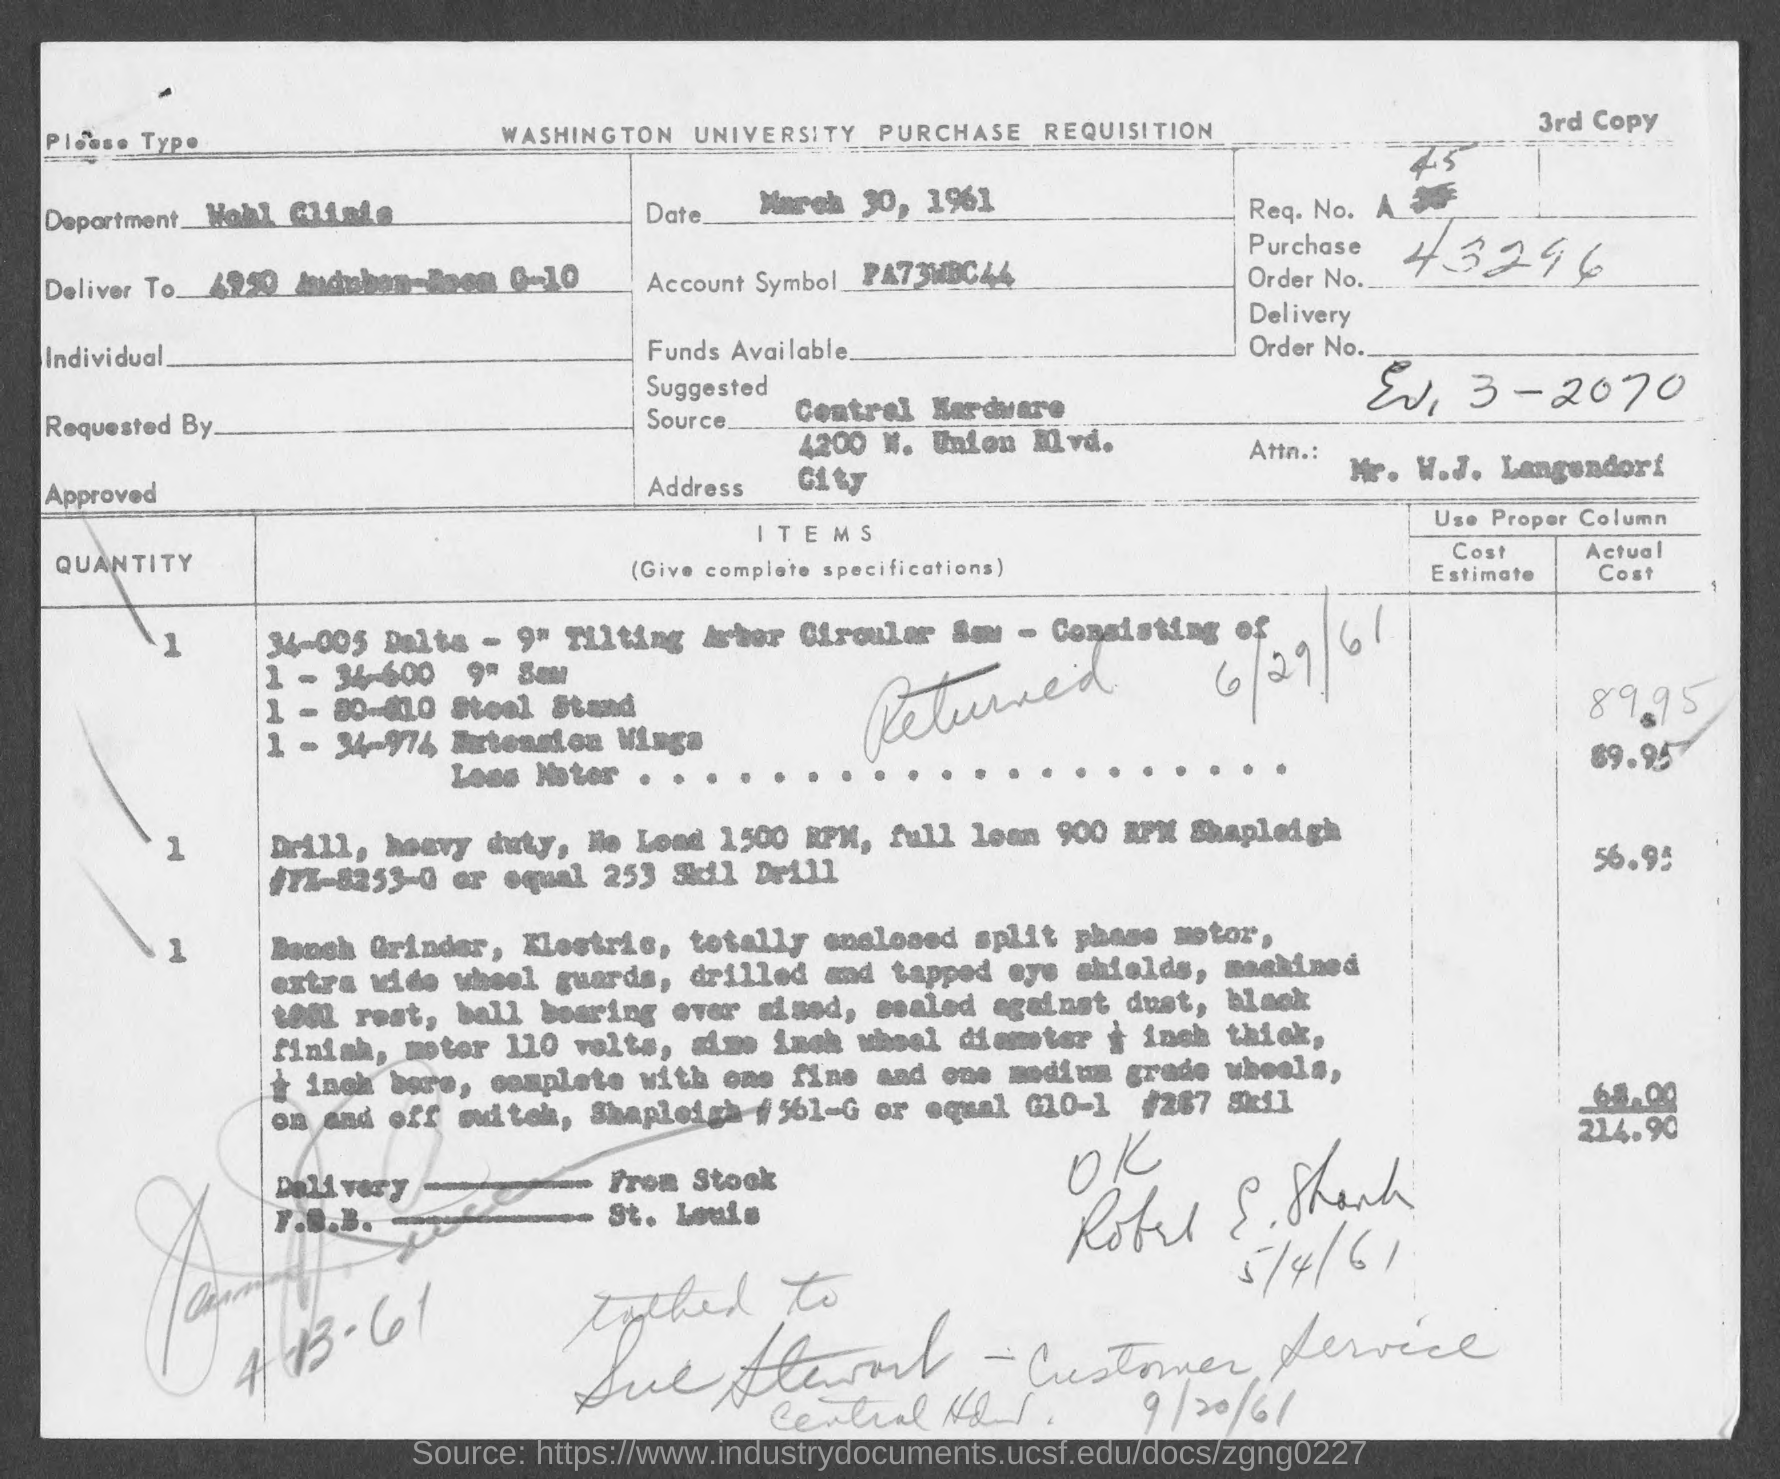List a handful of essential elements in this visual. The account symbol mentioned in the document is "PA73WBC44..". The issued date of this document is March 30, 1961. The document contains a purchase order number, 43296. 